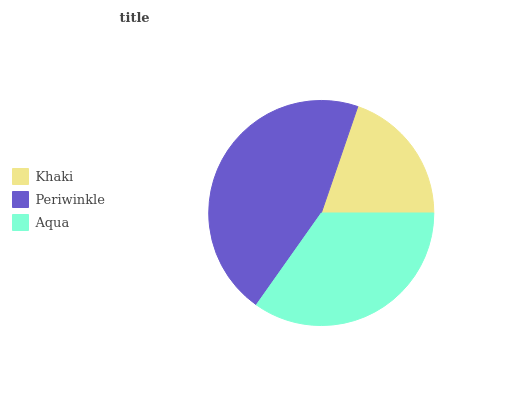Is Khaki the minimum?
Answer yes or no. Yes. Is Periwinkle the maximum?
Answer yes or no. Yes. Is Aqua the minimum?
Answer yes or no. No. Is Aqua the maximum?
Answer yes or no. No. Is Periwinkle greater than Aqua?
Answer yes or no. Yes. Is Aqua less than Periwinkle?
Answer yes or no. Yes. Is Aqua greater than Periwinkle?
Answer yes or no. No. Is Periwinkle less than Aqua?
Answer yes or no. No. Is Aqua the high median?
Answer yes or no. Yes. Is Aqua the low median?
Answer yes or no. Yes. Is Periwinkle the high median?
Answer yes or no. No. Is Khaki the low median?
Answer yes or no. No. 